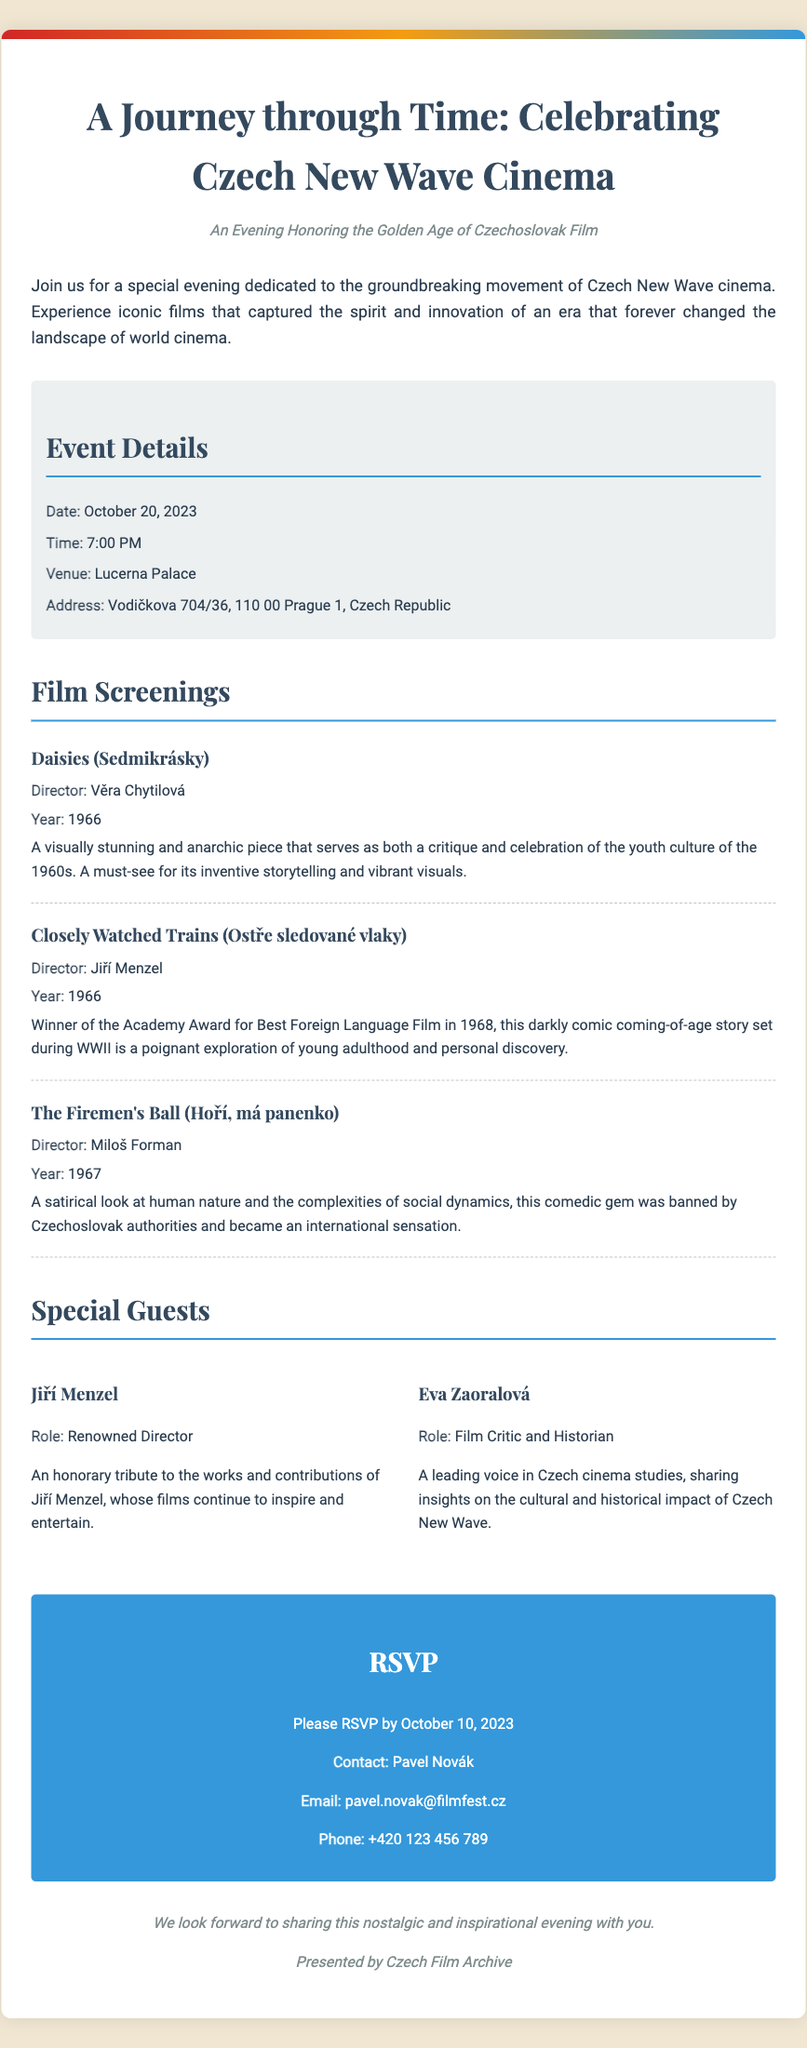what is the date of the event? The event date is explicitly mentioned in the document.
Answer: October 20, 2023 what is the venue of the film screening? The document states the venue where the event will take place.
Answer: Lucerna Palace who directed 'Daisies'? The document lists the director of the film 'Daisies'.
Answer: Věra Chytilová how many films are listed in the program? The document provides a total count of films mentioned in the screening section.
Answer: Three who is one of the special guests attending? The document includes names of special guests who will attend the event.
Answer: Jiří Menzel what is the RSVP deadline? The document clearly specifies the date by which guests should RSVP.
Answer: October 10, 2023 what type of event is being celebrated? The document highlights the thematic focus of the event.
Answer: Czech New Wave Cinema who is the contact person for RSVP? The document mentions the person responsible for handling RSVPs.
Answer: Pavel Novák 